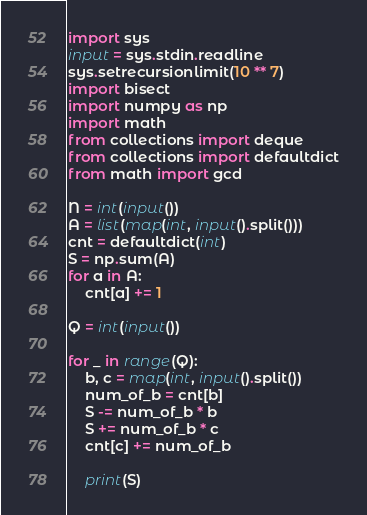Convert code to text. <code><loc_0><loc_0><loc_500><loc_500><_Python_>import sys
input = sys.stdin.readline
sys.setrecursionlimit(10 ** 7)
import bisect
import numpy as np
import math
from collections import deque
from collections import defaultdict
from math import gcd

N = int(input())
A = list(map(int, input().split()))
cnt = defaultdict(int)
S = np.sum(A)
for a in A:
    cnt[a] += 1

Q = int(input())

for _ in range(Q):
    b, c = map(int, input().split())
    num_of_b = cnt[b]
    S -= num_of_b * b
    S += num_of_b * c
    cnt[c] += num_of_b

    print(S)

</code> 